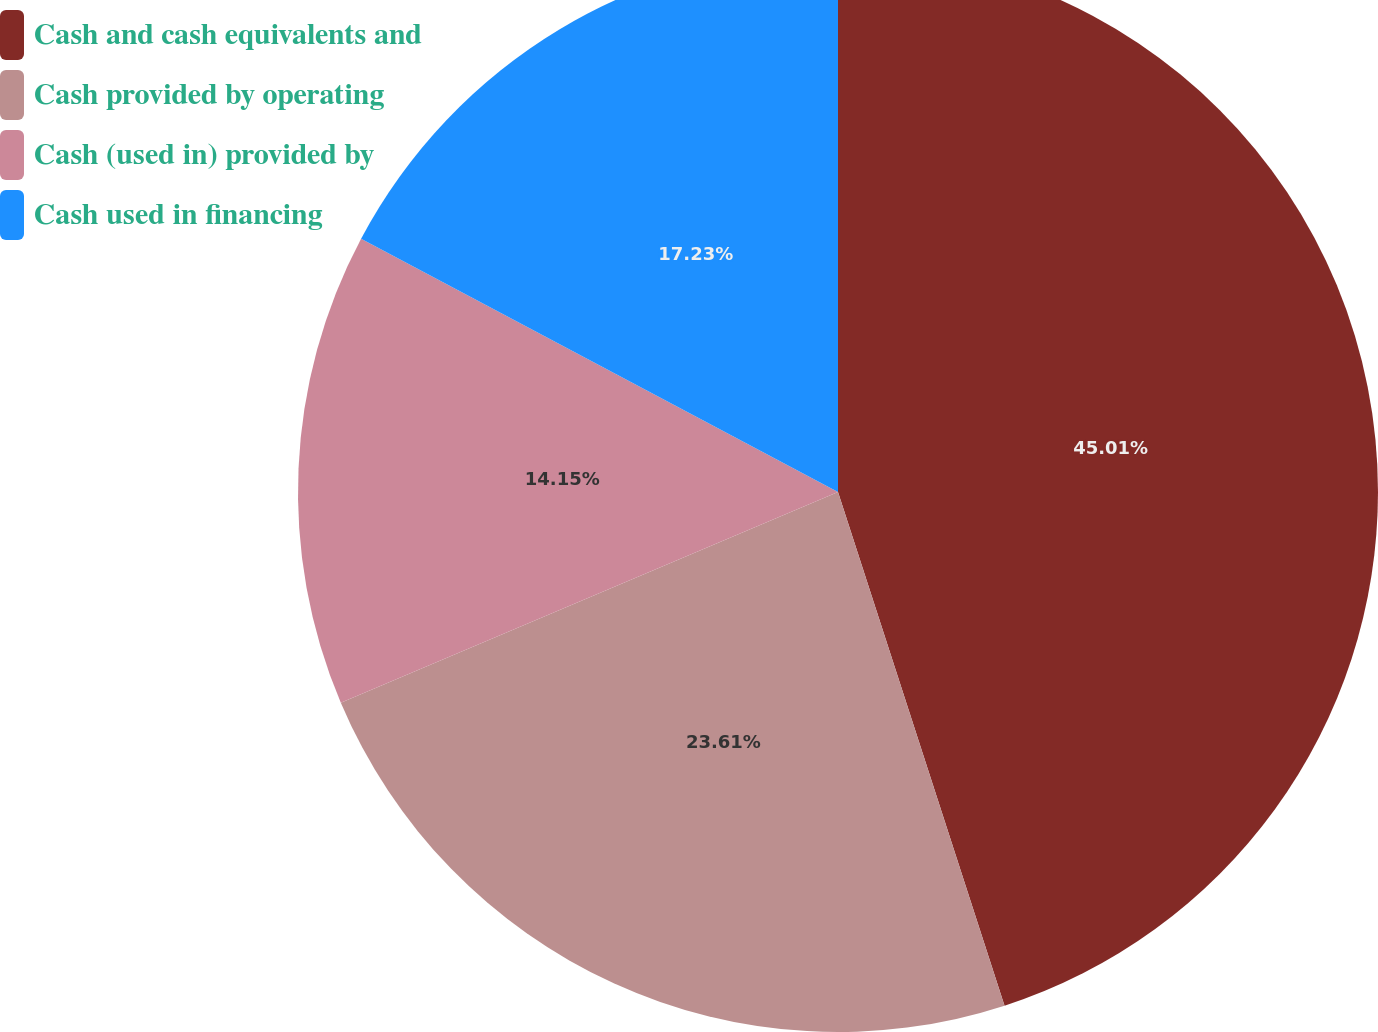Convert chart to OTSL. <chart><loc_0><loc_0><loc_500><loc_500><pie_chart><fcel>Cash and cash equivalents and<fcel>Cash provided by operating<fcel>Cash (used in) provided by<fcel>Cash used in financing<nl><fcel>45.01%<fcel>23.61%<fcel>14.15%<fcel>17.23%<nl></chart> 